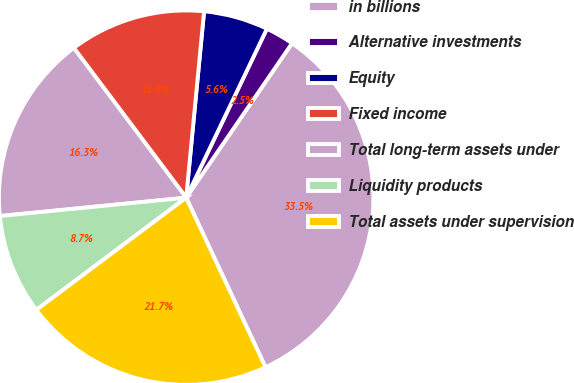<chart> <loc_0><loc_0><loc_500><loc_500><pie_chart><fcel>in billions<fcel>Alternative investments<fcel>Equity<fcel>Fixed income<fcel>Total long-term assets under<fcel>Liquidity products<fcel>Total assets under supervision<nl><fcel>33.47%<fcel>2.47%<fcel>5.57%<fcel>11.77%<fcel>16.32%<fcel>8.67%<fcel>21.73%<nl></chart> 